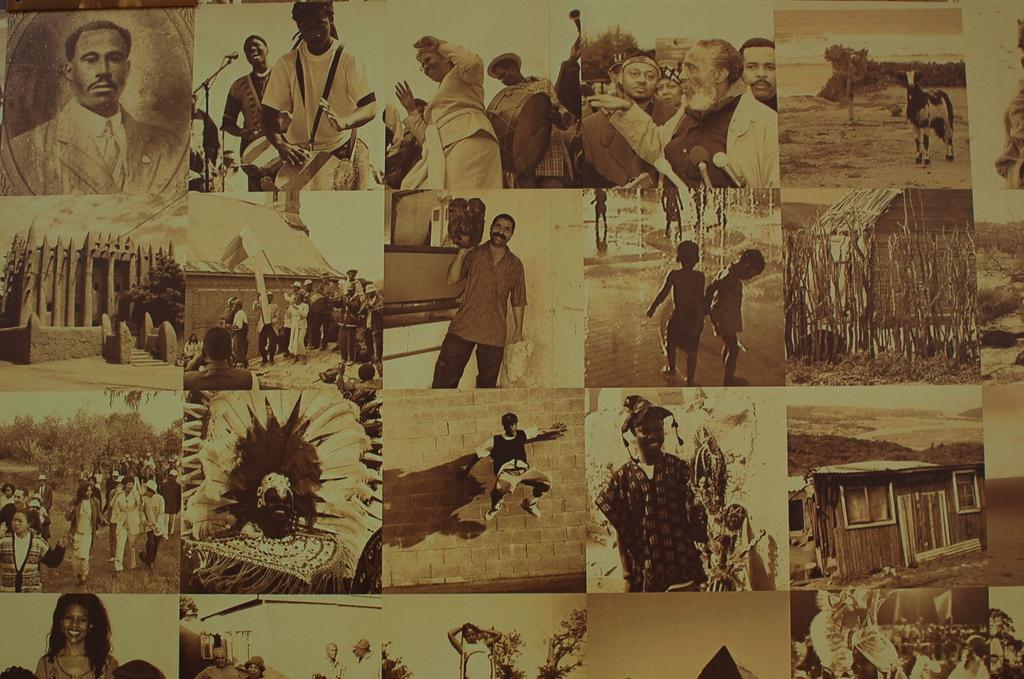Could you give a brief overview of what you see in this image? Here in this picture we can see number of photographs mixed up and kept at one place over there. 